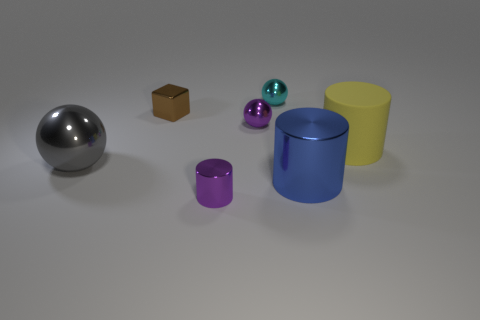Imagine these objects were part of a game. How might they be used? In a game setting, these objects could serve different purposes: the sphere could be a player's token, moving across a board; the cylinders and box could act as containers or obstacles; and the small spheres might be collectibles or resources that players can gather. 